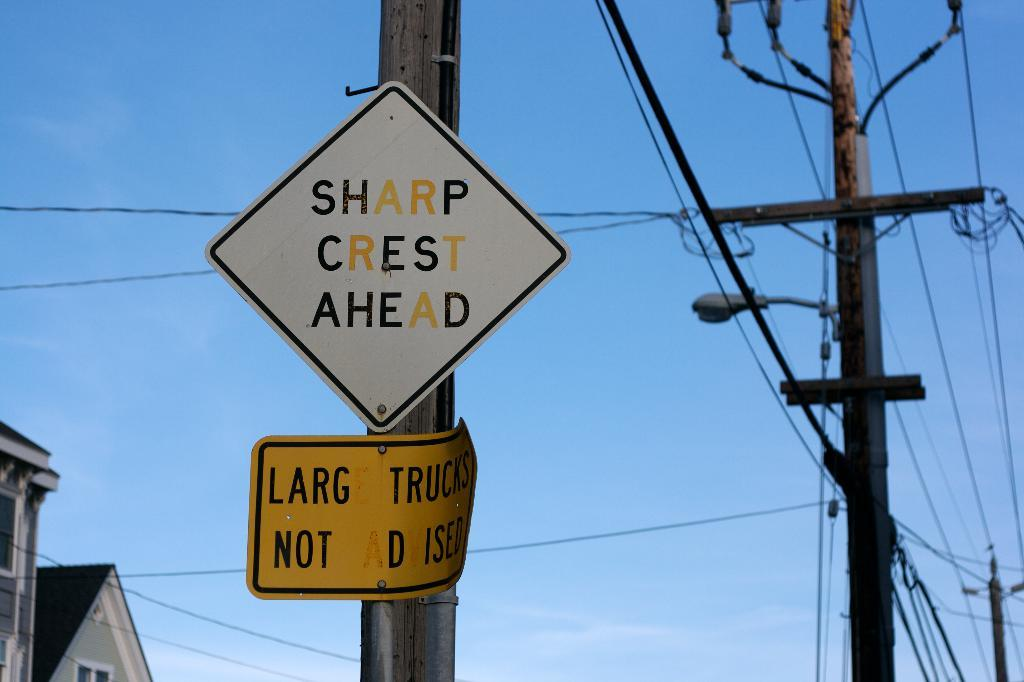<image>
Summarize the visual content of the image. A diamond shaped black and white street sign reads sharp crest ahead. 